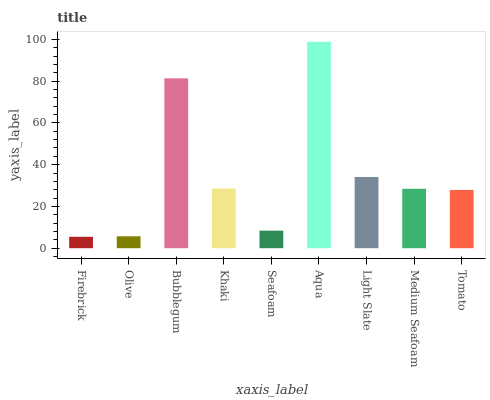Is Firebrick the minimum?
Answer yes or no. Yes. Is Aqua the maximum?
Answer yes or no. Yes. Is Olive the minimum?
Answer yes or no. No. Is Olive the maximum?
Answer yes or no. No. Is Olive greater than Firebrick?
Answer yes or no. Yes. Is Firebrick less than Olive?
Answer yes or no. Yes. Is Firebrick greater than Olive?
Answer yes or no. No. Is Olive less than Firebrick?
Answer yes or no. No. Is Medium Seafoam the high median?
Answer yes or no. Yes. Is Medium Seafoam the low median?
Answer yes or no. Yes. Is Tomato the high median?
Answer yes or no. No. Is Bubblegum the low median?
Answer yes or no. No. 